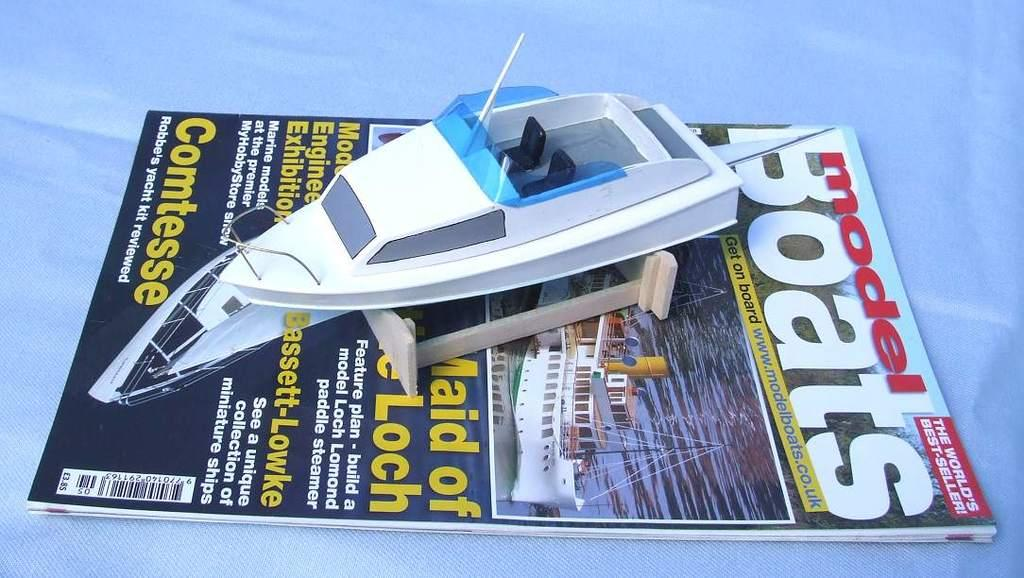<image>
Render a clear and concise summary of the photo. Magazine cover which has the word "Comtesse" on the front. 